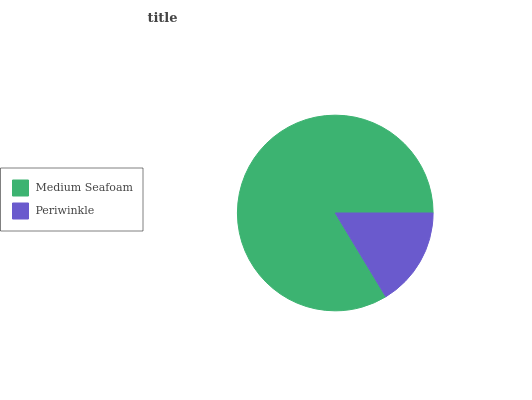Is Periwinkle the minimum?
Answer yes or no. Yes. Is Medium Seafoam the maximum?
Answer yes or no. Yes. Is Periwinkle the maximum?
Answer yes or no. No. Is Medium Seafoam greater than Periwinkle?
Answer yes or no. Yes. Is Periwinkle less than Medium Seafoam?
Answer yes or no. Yes. Is Periwinkle greater than Medium Seafoam?
Answer yes or no. No. Is Medium Seafoam less than Periwinkle?
Answer yes or no. No. Is Medium Seafoam the high median?
Answer yes or no. Yes. Is Periwinkle the low median?
Answer yes or no. Yes. Is Periwinkle the high median?
Answer yes or no. No. Is Medium Seafoam the low median?
Answer yes or no. No. 